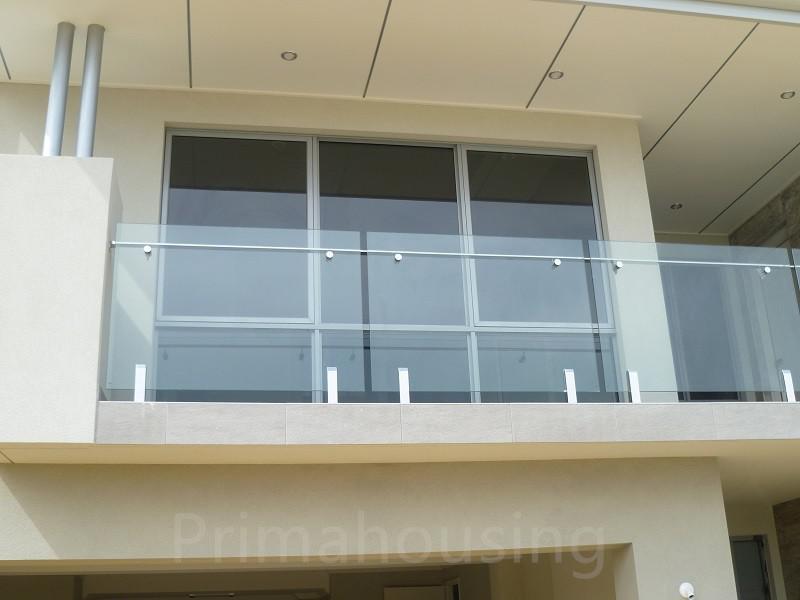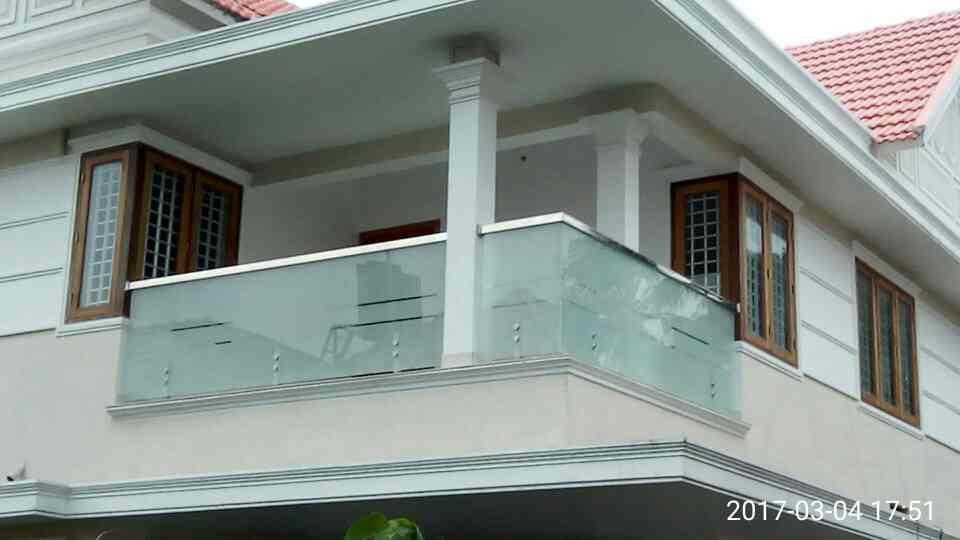The first image is the image on the left, the second image is the image on the right. For the images shown, is this caption "there is a wooden deck with glass surrounding it, overlooking the water" true? Answer yes or no. No. The first image is the image on the left, the second image is the image on the right. Examine the images to the left and right. Is the description "In one image, a glass-paneled balcony with a 'plank' floor overlooks the ocean on the right." accurate? Answer yes or no. No. 